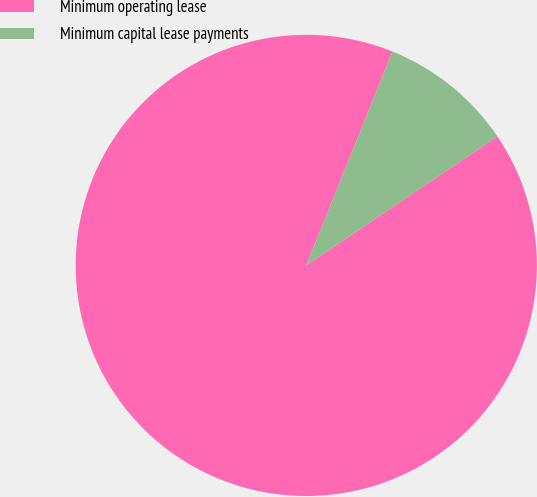<chart> <loc_0><loc_0><loc_500><loc_500><pie_chart><fcel>Minimum operating lease<fcel>Minimum capital lease payments<nl><fcel>90.55%<fcel>9.45%<nl></chart> 